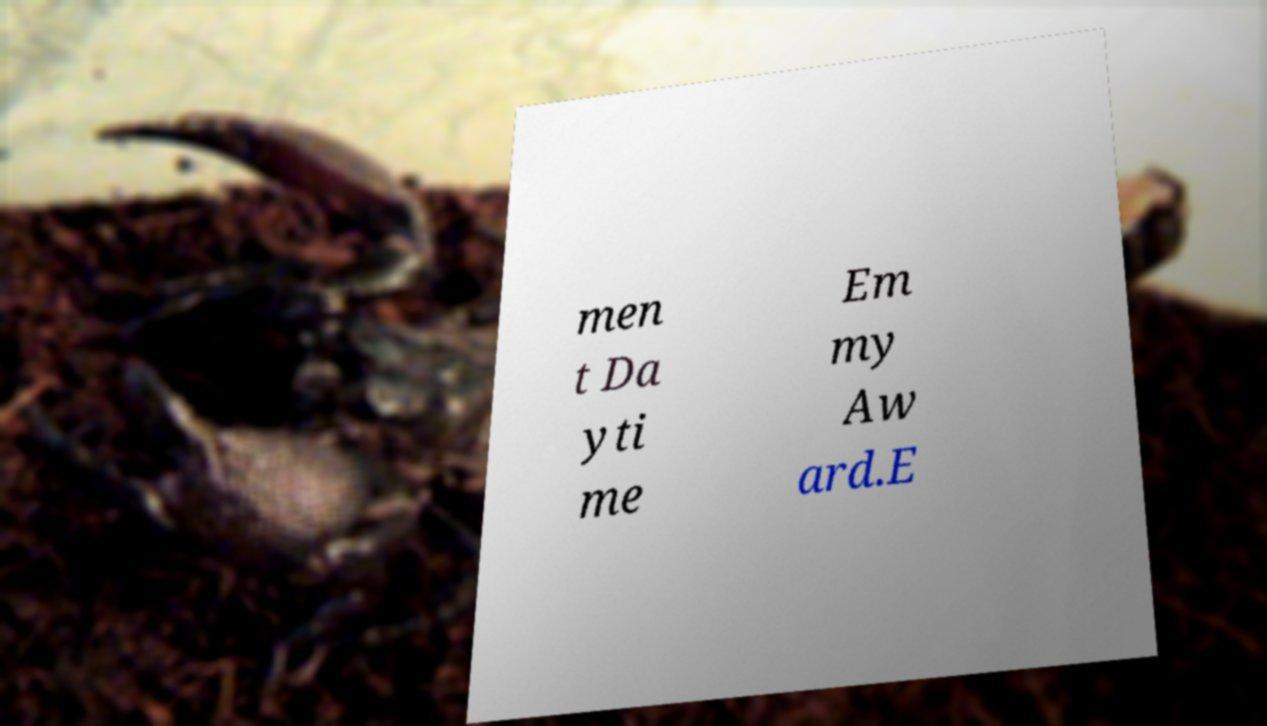Please identify and transcribe the text found in this image. men t Da yti me Em my Aw ard.E 